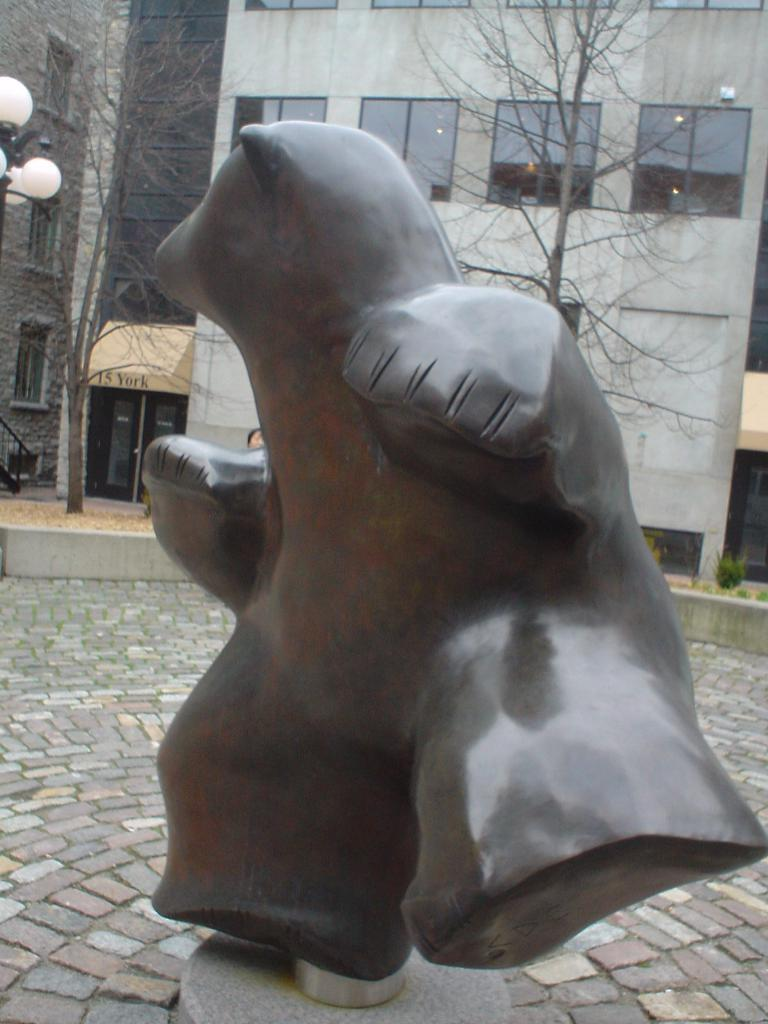What is the main subject of the image? There is a statue in the image. Where is the statue located? The statue is on a platform. What can be seen in the background of the image? There are buildings, windows, glass doors, plants, lights on a pole, and other objects in the background of the image. How many feet does the duck have in the image? There is no duck present in the image, so it is not possible to determine the number of feet it might have. 